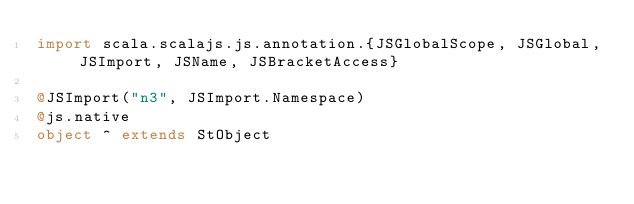<code> <loc_0><loc_0><loc_500><loc_500><_Scala_>import scala.scalajs.js.annotation.{JSGlobalScope, JSGlobal, JSImport, JSName, JSBracketAccess}

@JSImport("n3", JSImport.Namespace)
@js.native
object ^ extends StObject
</code> 